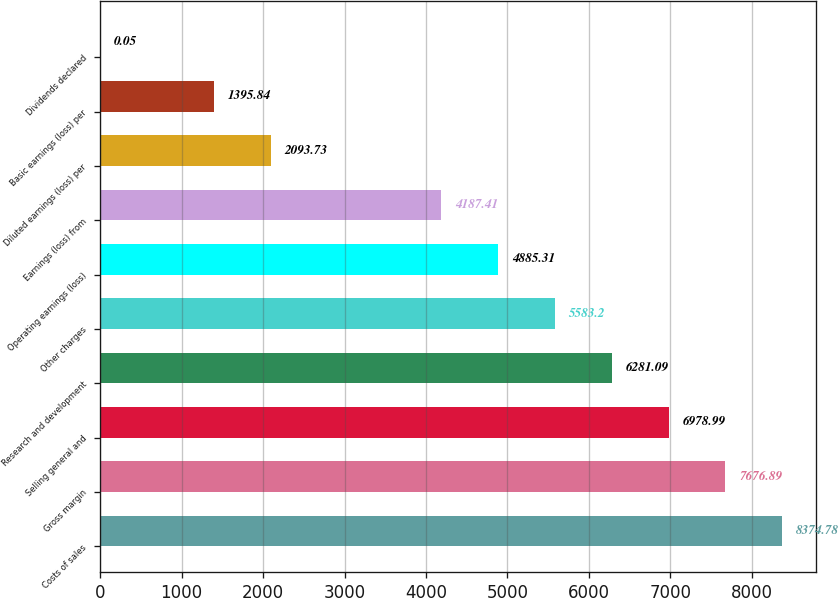Convert chart to OTSL. <chart><loc_0><loc_0><loc_500><loc_500><bar_chart><fcel>Costs of sales<fcel>Gross margin<fcel>Selling general and<fcel>Research and development<fcel>Other charges<fcel>Operating earnings (loss)<fcel>Earnings (loss) from<fcel>Diluted earnings (loss) per<fcel>Basic earnings (loss) per<fcel>Dividends declared<nl><fcel>8374.78<fcel>7676.89<fcel>6978.99<fcel>6281.09<fcel>5583.2<fcel>4885.31<fcel>4187.41<fcel>2093.73<fcel>1395.84<fcel>0.05<nl></chart> 